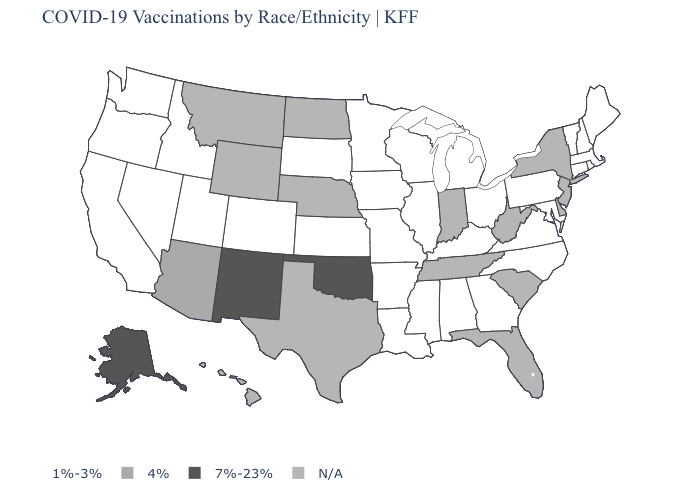Name the states that have a value in the range N/A?
Keep it brief. Delaware, Florida, Hawaii, Indiana, Montana, Nebraska, New Jersey, New York, North Dakota, South Carolina, Tennessee, Texas, West Virginia, Wyoming. What is the value of Idaho?
Quick response, please. 1%-3%. What is the lowest value in states that border Connecticut?
Short answer required. 1%-3%. What is the highest value in the USA?
Give a very brief answer. 7%-23%. Which states have the lowest value in the USA?
Write a very short answer. Alabama, Arkansas, California, Colorado, Connecticut, Georgia, Idaho, Illinois, Iowa, Kansas, Kentucky, Louisiana, Maine, Maryland, Massachusetts, Michigan, Minnesota, Mississippi, Missouri, Nevada, New Hampshire, North Carolina, Ohio, Oregon, Pennsylvania, Rhode Island, South Dakota, Utah, Vermont, Virginia, Washington, Wisconsin. Name the states that have a value in the range 1%-3%?
Quick response, please. Alabama, Arkansas, California, Colorado, Connecticut, Georgia, Idaho, Illinois, Iowa, Kansas, Kentucky, Louisiana, Maine, Maryland, Massachusetts, Michigan, Minnesota, Mississippi, Missouri, Nevada, New Hampshire, North Carolina, Ohio, Oregon, Pennsylvania, Rhode Island, South Dakota, Utah, Vermont, Virginia, Washington, Wisconsin. How many symbols are there in the legend?
Keep it brief. 4. What is the lowest value in the Northeast?
Give a very brief answer. 1%-3%. Which states hav the highest value in the West?
Short answer required. Alaska, New Mexico. Name the states that have a value in the range 7%-23%?
Be succinct. Alaska, New Mexico, Oklahoma. What is the value of Oklahoma?
Be succinct. 7%-23%. Among the states that border Minnesota , which have the highest value?
Be succinct. Iowa, South Dakota, Wisconsin. Does Alaska have the lowest value in the West?
Quick response, please. No. 